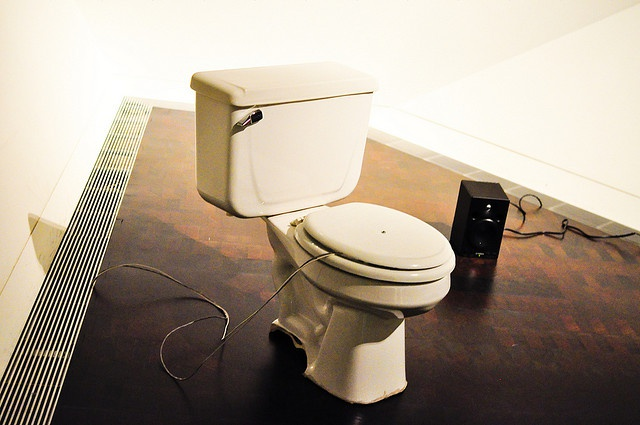Describe the objects in this image and their specific colors. I can see a toilet in beige, tan, and gray tones in this image. 